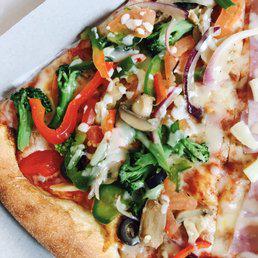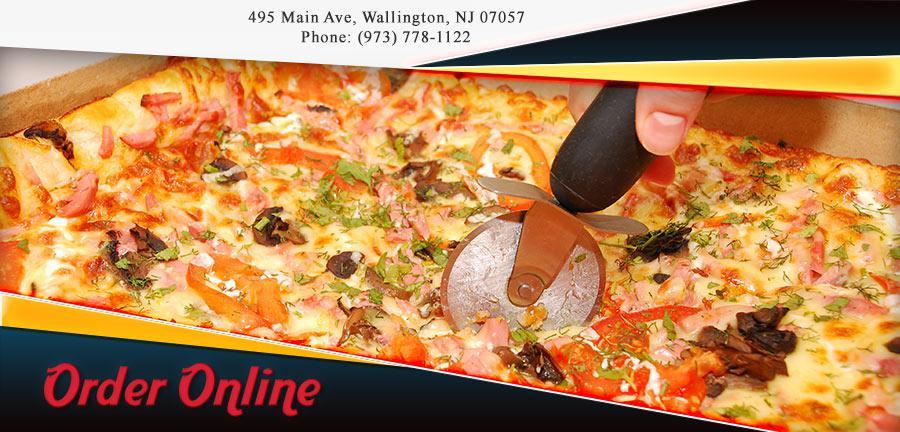The first image is the image on the left, the second image is the image on the right. Evaluate the accuracy of this statement regarding the images: "There is a single slice of pizza on a paper plate.". Is it true? Answer yes or no. No. 